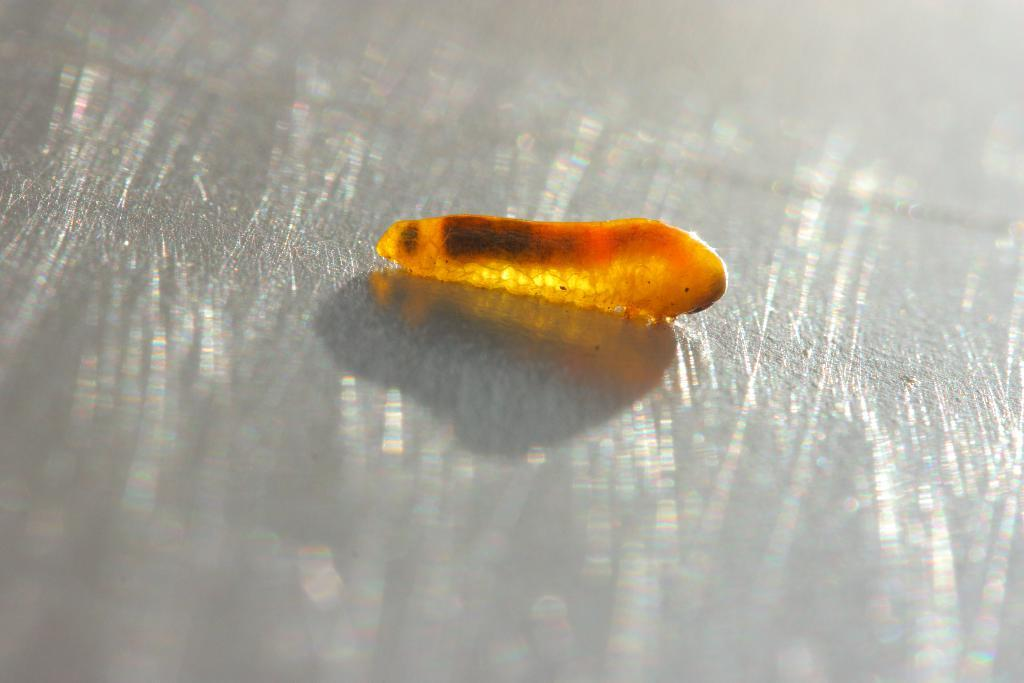What type of creature can be seen in the image? There is an insect in the image. Where is the insect located in the image? The insect is on a platform. What type of plants can be seen growing on the insect in the image? There are no plants visible on the insect in the image. What type of joke is the insect telling in the image? There is no indication of a joke or any humor in the image; it simply features an insect on a platform. 